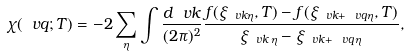Convert formula to latex. <formula><loc_0><loc_0><loc_500><loc_500>\chi ( \ v q ; T ) = - 2 \sum _ { \eta } \int \frac { d \ v k } { ( 2 \pi ) ^ { 2 } } \frac { f ( \xi _ { \ v k \eta } , T ) - f ( \xi _ { \ v k + \ v q \eta } , T ) } { \xi _ { \ v k \, \eta } - \xi _ { \ v k + \ v q \, \eta } } ,</formula> 